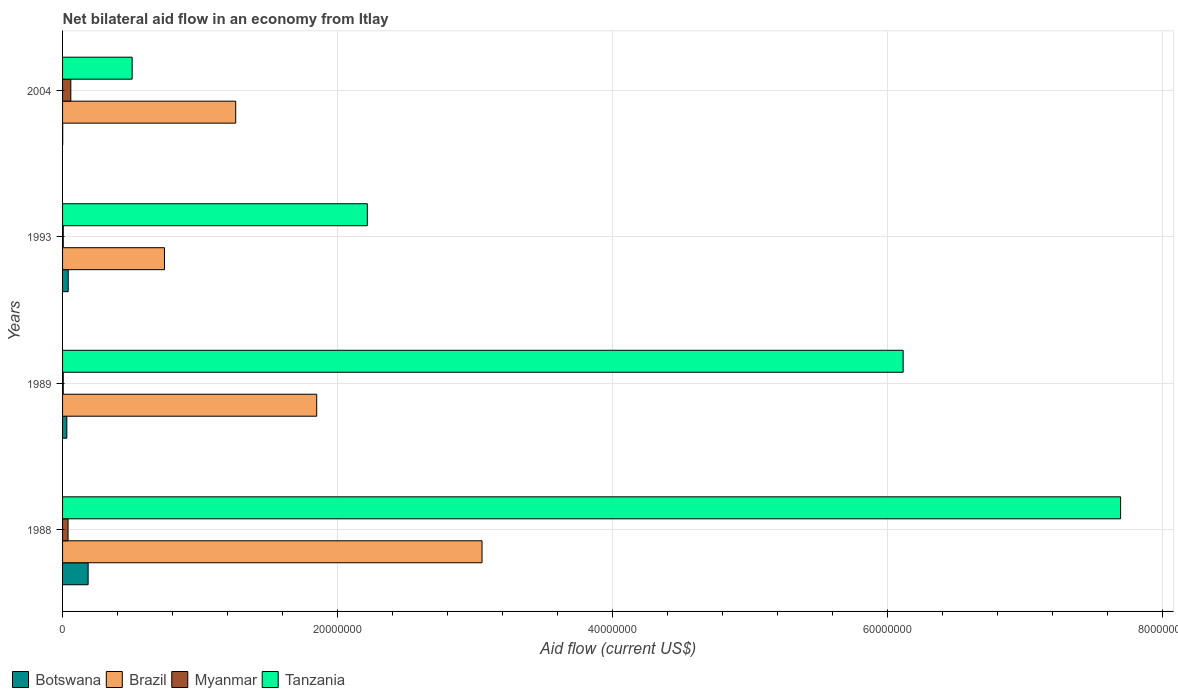How many different coloured bars are there?
Give a very brief answer. 4. How many groups of bars are there?
Keep it short and to the point. 4. Are the number of bars per tick equal to the number of legend labels?
Offer a very short reply. Yes. How many bars are there on the 4th tick from the top?
Offer a terse response. 4. In how many cases, is the number of bars for a given year not equal to the number of legend labels?
Make the answer very short. 0. Across all years, what is the maximum net bilateral aid flow in Tanzania?
Ensure brevity in your answer.  7.69e+07. Across all years, what is the minimum net bilateral aid flow in Brazil?
Make the answer very short. 7.41e+06. What is the total net bilateral aid flow in Tanzania in the graph?
Offer a terse response. 1.65e+08. What is the difference between the net bilateral aid flow in Tanzania in 2004 and the net bilateral aid flow in Brazil in 1988?
Provide a short and direct response. -2.54e+07. What is the average net bilateral aid flow in Brazil per year?
Keep it short and to the point. 1.72e+07. In the year 1993, what is the difference between the net bilateral aid flow in Botswana and net bilateral aid flow in Brazil?
Ensure brevity in your answer.  -7.00e+06. What is the ratio of the net bilateral aid flow in Tanzania in 1989 to that in 2004?
Ensure brevity in your answer.  12.08. Is the net bilateral aid flow in Botswana in 1993 less than that in 2004?
Your answer should be very brief. No. Is the difference between the net bilateral aid flow in Botswana in 1988 and 1989 greater than the difference between the net bilateral aid flow in Brazil in 1988 and 1989?
Keep it short and to the point. No. What is the difference between the highest and the second highest net bilateral aid flow in Brazil?
Ensure brevity in your answer.  1.20e+07. What is the difference between the highest and the lowest net bilateral aid flow in Tanzania?
Your answer should be compact. 7.19e+07. In how many years, is the net bilateral aid flow in Tanzania greater than the average net bilateral aid flow in Tanzania taken over all years?
Keep it short and to the point. 2. Is the sum of the net bilateral aid flow in Myanmar in 1988 and 2004 greater than the maximum net bilateral aid flow in Botswana across all years?
Make the answer very short. No. Is it the case that in every year, the sum of the net bilateral aid flow in Myanmar and net bilateral aid flow in Botswana is greater than the sum of net bilateral aid flow in Tanzania and net bilateral aid flow in Brazil?
Your answer should be compact. No. What does the 2nd bar from the top in 1989 represents?
Provide a short and direct response. Myanmar. What does the 1st bar from the bottom in 1989 represents?
Ensure brevity in your answer.  Botswana. Is it the case that in every year, the sum of the net bilateral aid flow in Myanmar and net bilateral aid flow in Tanzania is greater than the net bilateral aid flow in Brazil?
Your answer should be compact. No. Are all the bars in the graph horizontal?
Your answer should be very brief. Yes. How many years are there in the graph?
Keep it short and to the point. 4. What is the difference between two consecutive major ticks on the X-axis?
Offer a very short reply. 2.00e+07. Does the graph contain grids?
Your answer should be compact. Yes. Where does the legend appear in the graph?
Provide a succinct answer. Bottom left. How are the legend labels stacked?
Make the answer very short. Horizontal. What is the title of the graph?
Give a very brief answer. Net bilateral aid flow in an economy from Itlay. What is the label or title of the X-axis?
Ensure brevity in your answer.  Aid flow (current US$). What is the Aid flow (current US$) in Botswana in 1988?
Offer a very short reply. 1.86e+06. What is the Aid flow (current US$) in Brazil in 1988?
Provide a short and direct response. 3.05e+07. What is the Aid flow (current US$) of Tanzania in 1988?
Keep it short and to the point. 7.69e+07. What is the Aid flow (current US$) of Botswana in 1989?
Offer a very short reply. 3.10e+05. What is the Aid flow (current US$) of Brazil in 1989?
Ensure brevity in your answer.  1.85e+07. What is the Aid flow (current US$) in Myanmar in 1989?
Give a very brief answer. 5.00e+04. What is the Aid flow (current US$) of Tanzania in 1989?
Offer a terse response. 6.11e+07. What is the Aid flow (current US$) of Brazil in 1993?
Keep it short and to the point. 7.41e+06. What is the Aid flow (current US$) in Tanzania in 1993?
Keep it short and to the point. 2.22e+07. What is the Aid flow (current US$) of Brazil in 2004?
Provide a succinct answer. 1.26e+07. What is the Aid flow (current US$) in Tanzania in 2004?
Your answer should be very brief. 5.06e+06. Across all years, what is the maximum Aid flow (current US$) in Botswana?
Offer a very short reply. 1.86e+06. Across all years, what is the maximum Aid flow (current US$) of Brazil?
Your answer should be compact. 3.05e+07. Across all years, what is the maximum Aid flow (current US$) of Tanzania?
Your answer should be compact. 7.69e+07. Across all years, what is the minimum Aid flow (current US$) in Botswana?
Offer a terse response. 10000. Across all years, what is the minimum Aid flow (current US$) in Brazil?
Provide a short and direct response. 7.41e+06. Across all years, what is the minimum Aid flow (current US$) in Tanzania?
Keep it short and to the point. 5.06e+06. What is the total Aid flow (current US$) in Botswana in the graph?
Ensure brevity in your answer.  2.59e+06. What is the total Aid flow (current US$) of Brazil in the graph?
Your answer should be very brief. 6.90e+07. What is the total Aid flow (current US$) in Myanmar in the graph?
Provide a short and direct response. 1.10e+06. What is the total Aid flow (current US$) of Tanzania in the graph?
Your response must be concise. 1.65e+08. What is the difference between the Aid flow (current US$) in Botswana in 1988 and that in 1989?
Provide a succinct answer. 1.55e+06. What is the difference between the Aid flow (current US$) of Brazil in 1988 and that in 1989?
Your answer should be compact. 1.20e+07. What is the difference between the Aid flow (current US$) in Myanmar in 1988 and that in 1989?
Your response must be concise. 3.50e+05. What is the difference between the Aid flow (current US$) in Tanzania in 1988 and that in 1989?
Ensure brevity in your answer.  1.58e+07. What is the difference between the Aid flow (current US$) of Botswana in 1988 and that in 1993?
Make the answer very short. 1.45e+06. What is the difference between the Aid flow (current US$) in Brazil in 1988 and that in 1993?
Ensure brevity in your answer.  2.31e+07. What is the difference between the Aid flow (current US$) of Myanmar in 1988 and that in 1993?
Offer a very short reply. 3.50e+05. What is the difference between the Aid flow (current US$) in Tanzania in 1988 and that in 1993?
Ensure brevity in your answer.  5.48e+07. What is the difference between the Aid flow (current US$) of Botswana in 1988 and that in 2004?
Offer a terse response. 1.85e+06. What is the difference between the Aid flow (current US$) of Brazil in 1988 and that in 2004?
Keep it short and to the point. 1.79e+07. What is the difference between the Aid flow (current US$) of Myanmar in 1988 and that in 2004?
Ensure brevity in your answer.  -2.00e+05. What is the difference between the Aid flow (current US$) in Tanzania in 1988 and that in 2004?
Ensure brevity in your answer.  7.19e+07. What is the difference between the Aid flow (current US$) of Botswana in 1989 and that in 1993?
Provide a short and direct response. -1.00e+05. What is the difference between the Aid flow (current US$) in Brazil in 1989 and that in 1993?
Your answer should be very brief. 1.11e+07. What is the difference between the Aid flow (current US$) in Myanmar in 1989 and that in 1993?
Make the answer very short. 0. What is the difference between the Aid flow (current US$) in Tanzania in 1989 and that in 1993?
Make the answer very short. 3.90e+07. What is the difference between the Aid flow (current US$) in Brazil in 1989 and that in 2004?
Your answer should be compact. 5.89e+06. What is the difference between the Aid flow (current US$) in Myanmar in 1989 and that in 2004?
Make the answer very short. -5.50e+05. What is the difference between the Aid flow (current US$) of Tanzania in 1989 and that in 2004?
Give a very brief answer. 5.61e+07. What is the difference between the Aid flow (current US$) of Botswana in 1993 and that in 2004?
Your response must be concise. 4.00e+05. What is the difference between the Aid flow (current US$) in Brazil in 1993 and that in 2004?
Keep it short and to the point. -5.18e+06. What is the difference between the Aid flow (current US$) in Myanmar in 1993 and that in 2004?
Your response must be concise. -5.50e+05. What is the difference between the Aid flow (current US$) in Tanzania in 1993 and that in 2004?
Your answer should be compact. 1.71e+07. What is the difference between the Aid flow (current US$) of Botswana in 1988 and the Aid flow (current US$) of Brazil in 1989?
Offer a very short reply. -1.66e+07. What is the difference between the Aid flow (current US$) in Botswana in 1988 and the Aid flow (current US$) in Myanmar in 1989?
Offer a terse response. 1.81e+06. What is the difference between the Aid flow (current US$) of Botswana in 1988 and the Aid flow (current US$) of Tanzania in 1989?
Your answer should be compact. -5.93e+07. What is the difference between the Aid flow (current US$) in Brazil in 1988 and the Aid flow (current US$) in Myanmar in 1989?
Your answer should be very brief. 3.04e+07. What is the difference between the Aid flow (current US$) of Brazil in 1988 and the Aid flow (current US$) of Tanzania in 1989?
Your response must be concise. -3.06e+07. What is the difference between the Aid flow (current US$) of Myanmar in 1988 and the Aid flow (current US$) of Tanzania in 1989?
Provide a succinct answer. -6.07e+07. What is the difference between the Aid flow (current US$) in Botswana in 1988 and the Aid flow (current US$) in Brazil in 1993?
Offer a terse response. -5.55e+06. What is the difference between the Aid flow (current US$) in Botswana in 1988 and the Aid flow (current US$) in Myanmar in 1993?
Offer a terse response. 1.81e+06. What is the difference between the Aid flow (current US$) of Botswana in 1988 and the Aid flow (current US$) of Tanzania in 1993?
Provide a short and direct response. -2.03e+07. What is the difference between the Aid flow (current US$) in Brazil in 1988 and the Aid flow (current US$) in Myanmar in 1993?
Offer a terse response. 3.04e+07. What is the difference between the Aid flow (current US$) in Brazil in 1988 and the Aid flow (current US$) in Tanzania in 1993?
Provide a short and direct response. 8.34e+06. What is the difference between the Aid flow (current US$) in Myanmar in 1988 and the Aid flow (current US$) in Tanzania in 1993?
Offer a terse response. -2.18e+07. What is the difference between the Aid flow (current US$) in Botswana in 1988 and the Aid flow (current US$) in Brazil in 2004?
Your response must be concise. -1.07e+07. What is the difference between the Aid flow (current US$) of Botswana in 1988 and the Aid flow (current US$) of Myanmar in 2004?
Offer a very short reply. 1.26e+06. What is the difference between the Aid flow (current US$) in Botswana in 1988 and the Aid flow (current US$) in Tanzania in 2004?
Keep it short and to the point. -3.20e+06. What is the difference between the Aid flow (current US$) of Brazil in 1988 and the Aid flow (current US$) of Myanmar in 2004?
Provide a succinct answer. 2.99e+07. What is the difference between the Aid flow (current US$) of Brazil in 1988 and the Aid flow (current US$) of Tanzania in 2004?
Your answer should be very brief. 2.54e+07. What is the difference between the Aid flow (current US$) of Myanmar in 1988 and the Aid flow (current US$) of Tanzania in 2004?
Offer a very short reply. -4.66e+06. What is the difference between the Aid flow (current US$) in Botswana in 1989 and the Aid flow (current US$) in Brazil in 1993?
Provide a short and direct response. -7.10e+06. What is the difference between the Aid flow (current US$) in Botswana in 1989 and the Aid flow (current US$) in Tanzania in 1993?
Provide a succinct answer. -2.18e+07. What is the difference between the Aid flow (current US$) of Brazil in 1989 and the Aid flow (current US$) of Myanmar in 1993?
Your response must be concise. 1.84e+07. What is the difference between the Aid flow (current US$) in Brazil in 1989 and the Aid flow (current US$) in Tanzania in 1993?
Provide a succinct answer. -3.68e+06. What is the difference between the Aid flow (current US$) of Myanmar in 1989 and the Aid flow (current US$) of Tanzania in 1993?
Provide a succinct answer. -2.21e+07. What is the difference between the Aid flow (current US$) in Botswana in 1989 and the Aid flow (current US$) in Brazil in 2004?
Your answer should be very brief. -1.23e+07. What is the difference between the Aid flow (current US$) in Botswana in 1989 and the Aid flow (current US$) in Tanzania in 2004?
Ensure brevity in your answer.  -4.75e+06. What is the difference between the Aid flow (current US$) in Brazil in 1989 and the Aid flow (current US$) in Myanmar in 2004?
Your answer should be compact. 1.79e+07. What is the difference between the Aid flow (current US$) in Brazil in 1989 and the Aid flow (current US$) in Tanzania in 2004?
Provide a short and direct response. 1.34e+07. What is the difference between the Aid flow (current US$) of Myanmar in 1989 and the Aid flow (current US$) of Tanzania in 2004?
Give a very brief answer. -5.01e+06. What is the difference between the Aid flow (current US$) of Botswana in 1993 and the Aid flow (current US$) of Brazil in 2004?
Your answer should be very brief. -1.22e+07. What is the difference between the Aid flow (current US$) in Botswana in 1993 and the Aid flow (current US$) in Tanzania in 2004?
Provide a succinct answer. -4.65e+06. What is the difference between the Aid flow (current US$) in Brazil in 1993 and the Aid flow (current US$) in Myanmar in 2004?
Provide a succinct answer. 6.81e+06. What is the difference between the Aid flow (current US$) of Brazil in 1993 and the Aid flow (current US$) of Tanzania in 2004?
Ensure brevity in your answer.  2.35e+06. What is the difference between the Aid flow (current US$) of Myanmar in 1993 and the Aid flow (current US$) of Tanzania in 2004?
Provide a succinct answer. -5.01e+06. What is the average Aid flow (current US$) of Botswana per year?
Offer a very short reply. 6.48e+05. What is the average Aid flow (current US$) of Brazil per year?
Provide a short and direct response. 1.72e+07. What is the average Aid flow (current US$) in Myanmar per year?
Provide a short and direct response. 2.75e+05. What is the average Aid flow (current US$) of Tanzania per year?
Your answer should be compact. 4.13e+07. In the year 1988, what is the difference between the Aid flow (current US$) of Botswana and Aid flow (current US$) of Brazil?
Provide a succinct answer. -2.86e+07. In the year 1988, what is the difference between the Aid flow (current US$) in Botswana and Aid flow (current US$) in Myanmar?
Your answer should be very brief. 1.46e+06. In the year 1988, what is the difference between the Aid flow (current US$) in Botswana and Aid flow (current US$) in Tanzania?
Make the answer very short. -7.51e+07. In the year 1988, what is the difference between the Aid flow (current US$) in Brazil and Aid flow (current US$) in Myanmar?
Your answer should be very brief. 3.01e+07. In the year 1988, what is the difference between the Aid flow (current US$) of Brazil and Aid flow (current US$) of Tanzania?
Your response must be concise. -4.64e+07. In the year 1988, what is the difference between the Aid flow (current US$) in Myanmar and Aid flow (current US$) in Tanzania?
Provide a short and direct response. -7.65e+07. In the year 1989, what is the difference between the Aid flow (current US$) of Botswana and Aid flow (current US$) of Brazil?
Your answer should be very brief. -1.82e+07. In the year 1989, what is the difference between the Aid flow (current US$) of Botswana and Aid flow (current US$) of Myanmar?
Make the answer very short. 2.60e+05. In the year 1989, what is the difference between the Aid flow (current US$) of Botswana and Aid flow (current US$) of Tanzania?
Provide a short and direct response. -6.08e+07. In the year 1989, what is the difference between the Aid flow (current US$) of Brazil and Aid flow (current US$) of Myanmar?
Your answer should be very brief. 1.84e+07. In the year 1989, what is the difference between the Aid flow (current US$) in Brazil and Aid flow (current US$) in Tanzania?
Give a very brief answer. -4.26e+07. In the year 1989, what is the difference between the Aid flow (current US$) of Myanmar and Aid flow (current US$) of Tanzania?
Offer a terse response. -6.11e+07. In the year 1993, what is the difference between the Aid flow (current US$) of Botswana and Aid flow (current US$) of Brazil?
Offer a terse response. -7.00e+06. In the year 1993, what is the difference between the Aid flow (current US$) of Botswana and Aid flow (current US$) of Tanzania?
Your answer should be very brief. -2.18e+07. In the year 1993, what is the difference between the Aid flow (current US$) of Brazil and Aid flow (current US$) of Myanmar?
Offer a very short reply. 7.36e+06. In the year 1993, what is the difference between the Aid flow (current US$) of Brazil and Aid flow (current US$) of Tanzania?
Your response must be concise. -1.48e+07. In the year 1993, what is the difference between the Aid flow (current US$) of Myanmar and Aid flow (current US$) of Tanzania?
Offer a terse response. -2.21e+07. In the year 2004, what is the difference between the Aid flow (current US$) in Botswana and Aid flow (current US$) in Brazil?
Offer a very short reply. -1.26e+07. In the year 2004, what is the difference between the Aid flow (current US$) of Botswana and Aid flow (current US$) of Myanmar?
Your answer should be very brief. -5.90e+05. In the year 2004, what is the difference between the Aid flow (current US$) in Botswana and Aid flow (current US$) in Tanzania?
Make the answer very short. -5.05e+06. In the year 2004, what is the difference between the Aid flow (current US$) of Brazil and Aid flow (current US$) of Myanmar?
Give a very brief answer. 1.20e+07. In the year 2004, what is the difference between the Aid flow (current US$) in Brazil and Aid flow (current US$) in Tanzania?
Offer a very short reply. 7.53e+06. In the year 2004, what is the difference between the Aid flow (current US$) in Myanmar and Aid flow (current US$) in Tanzania?
Your response must be concise. -4.46e+06. What is the ratio of the Aid flow (current US$) of Brazil in 1988 to that in 1989?
Ensure brevity in your answer.  1.65. What is the ratio of the Aid flow (current US$) of Myanmar in 1988 to that in 1989?
Keep it short and to the point. 8. What is the ratio of the Aid flow (current US$) in Tanzania in 1988 to that in 1989?
Offer a very short reply. 1.26. What is the ratio of the Aid flow (current US$) in Botswana in 1988 to that in 1993?
Keep it short and to the point. 4.54. What is the ratio of the Aid flow (current US$) in Brazil in 1988 to that in 1993?
Your answer should be very brief. 4.12. What is the ratio of the Aid flow (current US$) of Myanmar in 1988 to that in 1993?
Ensure brevity in your answer.  8. What is the ratio of the Aid flow (current US$) of Tanzania in 1988 to that in 1993?
Your answer should be compact. 3.47. What is the ratio of the Aid flow (current US$) of Botswana in 1988 to that in 2004?
Your answer should be very brief. 186. What is the ratio of the Aid flow (current US$) of Brazil in 1988 to that in 2004?
Provide a succinct answer. 2.42. What is the ratio of the Aid flow (current US$) in Tanzania in 1988 to that in 2004?
Give a very brief answer. 15.2. What is the ratio of the Aid flow (current US$) in Botswana in 1989 to that in 1993?
Keep it short and to the point. 0.76. What is the ratio of the Aid flow (current US$) in Brazil in 1989 to that in 1993?
Provide a succinct answer. 2.49. What is the ratio of the Aid flow (current US$) of Tanzania in 1989 to that in 1993?
Offer a very short reply. 2.76. What is the ratio of the Aid flow (current US$) in Brazil in 1989 to that in 2004?
Ensure brevity in your answer.  1.47. What is the ratio of the Aid flow (current US$) of Myanmar in 1989 to that in 2004?
Your answer should be very brief. 0.08. What is the ratio of the Aid flow (current US$) in Tanzania in 1989 to that in 2004?
Your answer should be compact. 12.08. What is the ratio of the Aid flow (current US$) in Brazil in 1993 to that in 2004?
Give a very brief answer. 0.59. What is the ratio of the Aid flow (current US$) in Myanmar in 1993 to that in 2004?
Your answer should be compact. 0.08. What is the ratio of the Aid flow (current US$) in Tanzania in 1993 to that in 2004?
Offer a terse response. 4.38. What is the difference between the highest and the second highest Aid flow (current US$) of Botswana?
Offer a very short reply. 1.45e+06. What is the difference between the highest and the second highest Aid flow (current US$) in Brazil?
Provide a short and direct response. 1.20e+07. What is the difference between the highest and the second highest Aid flow (current US$) in Tanzania?
Offer a very short reply. 1.58e+07. What is the difference between the highest and the lowest Aid flow (current US$) in Botswana?
Make the answer very short. 1.85e+06. What is the difference between the highest and the lowest Aid flow (current US$) in Brazil?
Ensure brevity in your answer.  2.31e+07. What is the difference between the highest and the lowest Aid flow (current US$) in Tanzania?
Keep it short and to the point. 7.19e+07. 